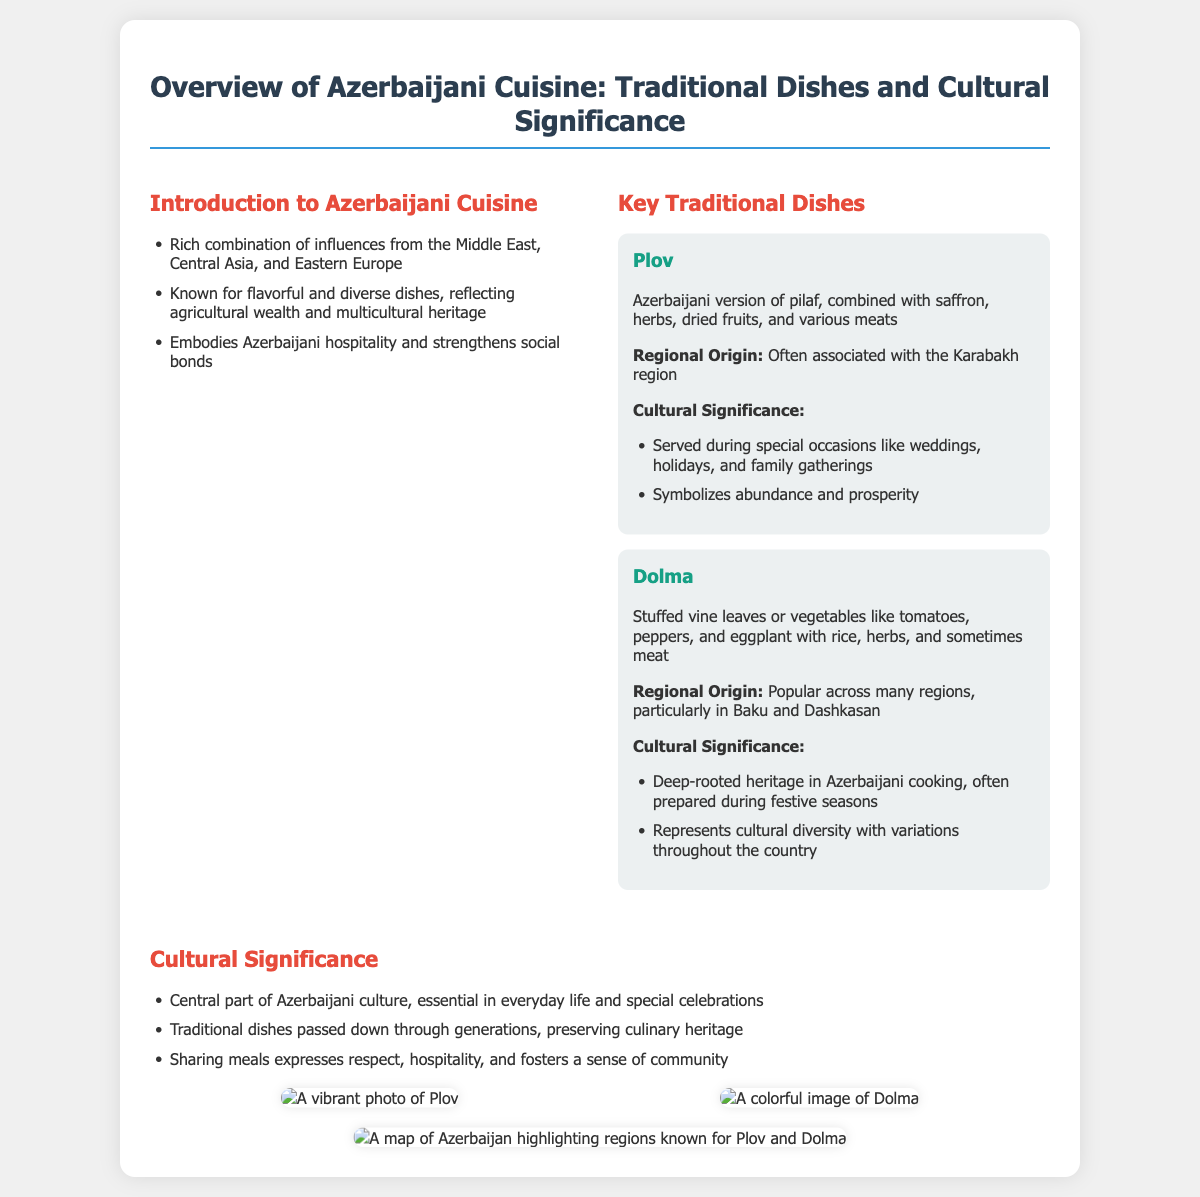What is Azerbaijani Plov? Plov is described as the Azerbaijani version of pilaf, combined with saffron, herbs, dried fruits, and various meats.
Answer: Azerbaijani version of pilaf What regions is Dolma popular in? The document states that Dolma is popular across many regions, particularly in Baku and Dashkasan.
Answer: Baku and Dashkasan During which occasions is Plov served? Plov is served during special occasions like weddings, holidays, and family gatherings.
Answer: Weddings, holidays, family gatherings What does Dolma represent in Azerbaijani culture? Dolma represents cultural diversity with variations throughout the country.
Answer: Cultural diversity What role does cuisine play in Azerbaijani culture? It is described as a central part of Azerbaijani culture, essential in everyday life and special celebrations.
Answer: Central part of Azerbaijani culture How many key traditional dishes are mentioned? The presentation mentions two key traditional dishes: Plov and Dolma.
Answer: Two What is the cultural significance of sharing meals? Sharing meals expresses respect, hospitality, and fosters a sense of community.
Answer: Respect, hospitality, community What is a key ingredient in Plov? Saffron is one of the key ingredients combined in Plov.
Answer: Saffron What is the title of this presentation slide? The title of the presentation slide is "Overview of Azerbaijani Cuisine: Traditional Dishes and Cultural Significance."
Answer: Overview of Azerbaijani Cuisine: Traditional Dishes and Cultural Significance 